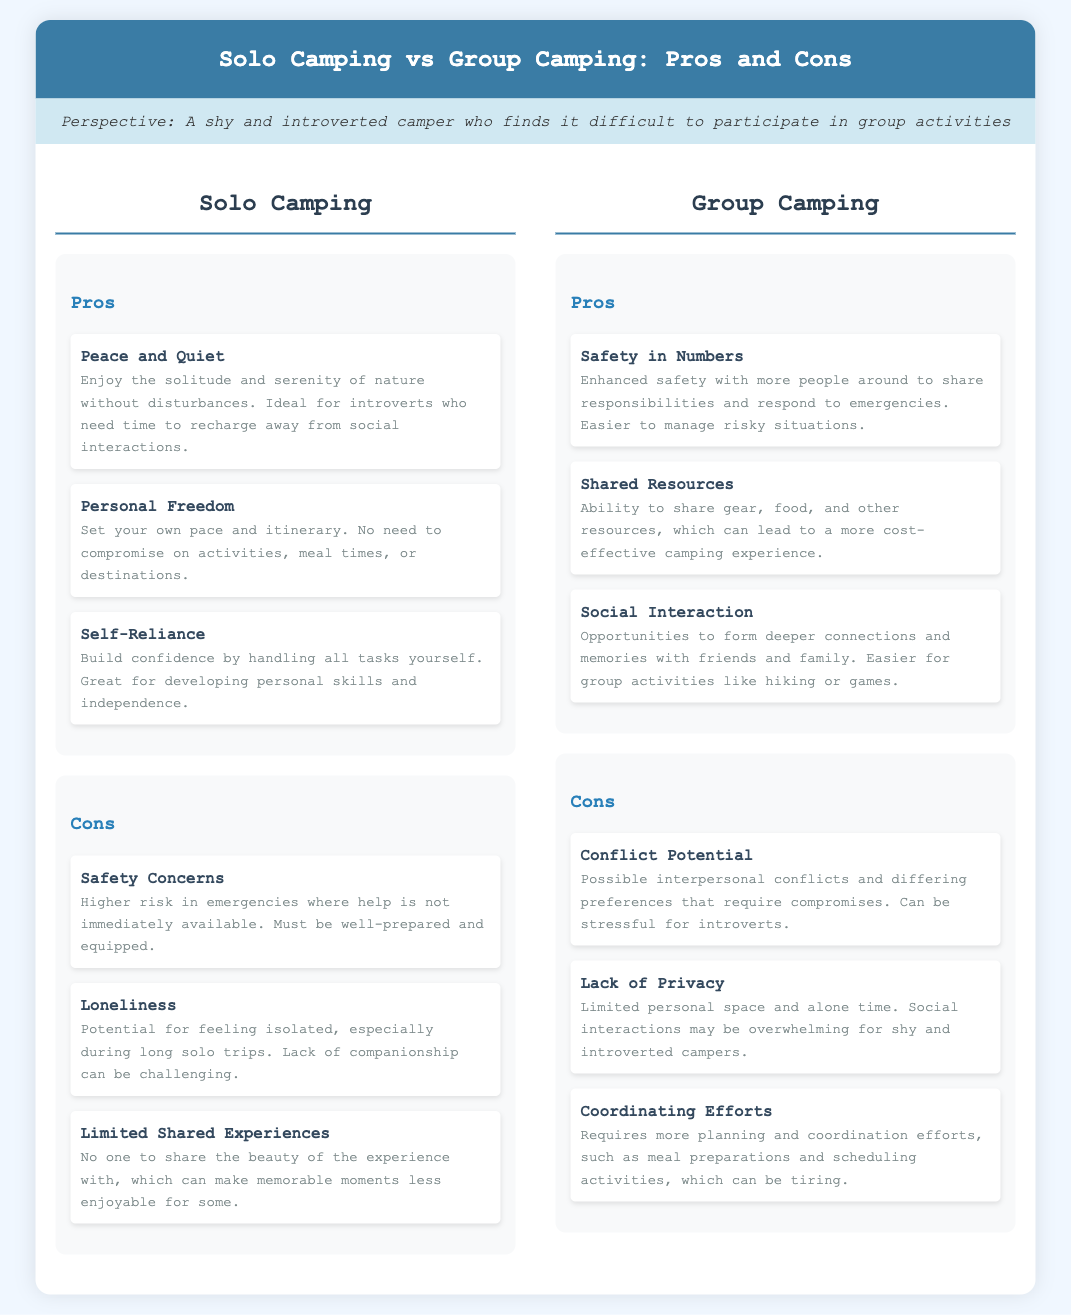What are the three pros of Solo Camping? The document lists three pros for Solo Camping, which are "Peace and Quiet," "Personal Freedom," and "Self-Reliance."
Answer: Peace and Quiet, Personal Freedom, Self-Reliance What is a con of Group Camping? One of the cons listed for Group Camping is "Conflict Potential."
Answer: Conflict Potential How does Solo Camping enhance one's independence? The document states that Solo Camping allows for "Self-Reliance," which builds confidence by handling tasks individually.
Answer: Self-Reliance What is a benefit of Group Camping regarding safety? Group Camping offers "Safety in Numbers," which enhances safety in emergencies with more people around.
Answer: Safety in Numbers Which camping type may lead to a feeling of loneliness? The document mentions that "Loneliness" is a con specifically for Solo Camping.
Answer: Loneliness What requires more planning, Solo or Group Camping? The document highlights that Group Camping involves "Coordinating Efforts," which requires more planning.
Answer: Group Camping How many pros are listed for each type of camping? Each type of camping has three pros listed in the document.
Answer: Three What is the title of the document? The title of the document is provided at the beginning and is "Solo Camping vs Group Camping: Pros and Cons."
Answer: Solo Camping vs Group Camping: Pros and Cons 